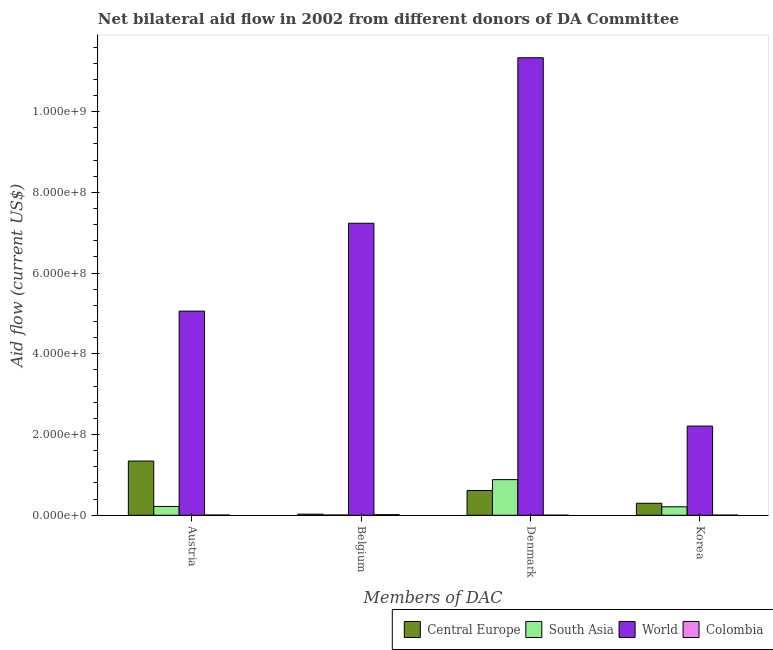How many different coloured bars are there?
Offer a terse response. 4. How many groups of bars are there?
Provide a short and direct response. 4. Are the number of bars on each tick of the X-axis equal?
Keep it short and to the point. Yes. How many bars are there on the 2nd tick from the left?
Provide a short and direct response. 4. What is the label of the 1st group of bars from the left?
Your answer should be very brief. Austria. What is the amount of aid given by austria in Colombia?
Provide a succinct answer. 5.50e+05. Across all countries, what is the maximum amount of aid given by denmark?
Offer a terse response. 1.13e+09. Across all countries, what is the minimum amount of aid given by belgium?
Your response must be concise. 6.20e+05. In which country was the amount of aid given by korea maximum?
Give a very brief answer. World. What is the total amount of aid given by denmark in the graph?
Your answer should be compact. 1.28e+09. What is the difference between the amount of aid given by denmark in South Asia and that in Colombia?
Your answer should be compact. 8.81e+07. What is the difference between the amount of aid given by korea in World and the amount of aid given by austria in Central Europe?
Give a very brief answer. 8.66e+07. What is the average amount of aid given by denmark per country?
Offer a very short reply. 3.21e+08. What is the difference between the amount of aid given by austria and amount of aid given by korea in Colombia?
Ensure brevity in your answer.  1.80e+05. What is the ratio of the amount of aid given by korea in Central Europe to that in South Asia?
Make the answer very short. 1.42. Is the difference between the amount of aid given by belgium in South Asia and Colombia greater than the difference between the amount of aid given by austria in South Asia and Colombia?
Keep it short and to the point. No. What is the difference between the highest and the second highest amount of aid given by denmark?
Your response must be concise. 1.05e+09. What is the difference between the highest and the lowest amount of aid given by korea?
Offer a terse response. 2.21e+08. What does the 2nd bar from the left in Denmark represents?
Your answer should be compact. South Asia. What does the 4th bar from the right in Belgium represents?
Provide a succinct answer. Central Europe. Is it the case that in every country, the sum of the amount of aid given by austria and amount of aid given by belgium is greater than the amount of aid given by denmark?
Your response must be concise. No. How many bars are there?
Ensure brevity in your answer.  16. Are all the bars in the graph horizontal?
Make the answer very short. No. Does the graph contain any zero values?
Your answer should be very brief. No. Does the graph contain grids?
Keep it short and to the point. No. How are the legend labels stacked?
Give a very brief answer. Horizontal. What is the title of the graph?
Ensure brevity in your answer.  Net bilateral aid flow in 2002 from different donors of DA Committee. Does "High income: OECD" appear as one of the legend labels in the graph?
Provide a short and direct response. No. What is the label or title of the X-axis?
Offer a terse response. Members of DAC. What is the Aid flow (current US$) in Central Europe in Austria?
Give a very brief answer. 1.34e+08. What is the Aid flow (current US$) of South Asia in Austria?
Provide a succinct answer. 2.18e+07. What is the Aid flow (current US$) of World in Austria?
Offer a terse response. 5.06e+08. What is the Aid flow (current US$) of Central Europe in Belgium?
Offer a terse response. 2.75e+06. What is the Aid flow (current US$) in South Asia in Belgium?
Ensure brevity in your answer.  6.20e+05. What is the Aid flow (current US$) of World in Belgium?
Offer a very short reply. 7.23e+08. What is the Aid flow (current US$) in Colombia in Belgium?
Your response must be concise. 1.44e+06. What is the Aid flow (current US$) of Central Europe in Denmark?
Offer a terse response. 6.13e+07. What is the Aid flow (current US$) in South Asia in Denmark?
Your response must be concise. 8.83e+07. What is the Aid flow (current US$) of World in Denmark?
Keep it short and to the point. 1.13e+09. What is the Aid flow (current US$) of Colombia in Denmark?
Offer a very short reply. 1.90e+05. What is the Aid flow (current US$) in Central Europe in Korea?
Your answer should be very brief. 2.97e+07. What is the Aid flow (current US$) in South Asia in Korea?
Make the answer very short. 2.10e+07. What is the Aid flow (current US$) in World in Korea?
Your answer should be very brief. 2.21e+08. What is the Aid flow (current US$) in Colombia in Korea?
Keep it short and to the point. 3.70e+05. Across all Members of DAC, what is the maximum Aid flow (current US$) of Central Europe?
Provide a succinct answer. 1.34e+08. Across all Members of DAC, what is the maximum Aid flow (current US$) in South Asia?
Your answer should be compact. 8.83e+07. Across all Members of DAC, what is the maximum Aid flow (current US$) of World?
Give a very brief answer. 1.13e+09. Across all Members of DAC, what is the maximum Aid flow (current US$) in Colombia?
Keep it short and to the point. 1.44e+06. Across all Members of DAC, what is the minimum Aid flow (current US$) of Central Europe?
Your answer should be very brief. 2.75e+06. Across all Members of DAC, what is the minimum Aid flow (current US$) in South Asia?
Make the answer very short. 6.20e+05. Across all Members of DAC, what is the minimum Aid flow (current US$) of World?
Your answer should be very brief. 2.21e+08. Across all Members of DAC, what is the minimum Aid flow (current US$) in Colombia?
Offer a very short reply. 1.90e+05. What is the total Aid flow (current US$) of Central Europe in the graph?
Provide a succinct answer. 2.28e+08. What is the total Aid flow (current US$) in South Asia in the graph?
Offer a very short reply. 1.32e+08. What is the total Aid flow (current US$) in World in the graph?
Your answer should be compact. 2.58e+09. What is the total Aid flow (current US$) in Colombia in the graph?
Give a very brief answer. 2.55e+06. What is the difference between the Aid flow (current US$) of Central Europe in Austria and that in Belgium?
Provide a succinct answer. 1.32e+08. What is the difference between the Aid flow (current US$) in South Asia in Austria and that in Belgium?
Ensure brevity in your answer.  2.12e+07. What is the difference between the Aid flow (current US$) in World in Austria and that in Belgium?
Provide a short and direct response. -2.18e+08. What is the difference between the Aid flow (current US$) in Colombia in Austria and that in Belgium?
Ensure brevity in your answer.  -8.90e+05. What is the difference between the Aid flow (current US$) of Central Europe in Austria and that in Denmark?
Make the answer very short. 7.30e+07. What is the difference between the Aid flow (current US$) in South Asia in Austria and that in Denmark?
Make the answer very short. -6.64e+07. What is the difference between the Aid flow (current US$) in World in Austria and that in Denmark?
Provide a short and direct response. -6.28e+08. What is the difference between the Aid flow (current US$) in Central Europe in Austria and that in Korea?
Keep it short and to the point. 1.05e+08. What is the difference between the Aid flow (current US$) in South Asia in Austria and that in Korea?
Keep it short and to the point. 8.80e+05. What is the difference between the Aid flow (current US$) of World in Austria and that in Korea?
Ensure brevity in your answer.  2.85e+08. What is the difference between the Aid flow (current US$) in Central Europe in Belgium and that in Denmark?
Provide a succinct answer. -5.86e+07. What is the difference between the Aid flow (current US$) of South Asia in Belgium and that in Denmark?
Offer a terse response. -8.76e+07. What is the difference between the Aid flow (current US$) in World in Belgium and that in Denmark?
Provide a short and direct response. -4.10e+08. What is the difference between the Aid flow (current US$) of Colombia in Belgium and that in Denmark?
Your answer should be compact. 1.25e+06. What is the difference between the Aid flow (current US$) of Central Europe in Belgium and that in Korea?
Give a very brief answer. -2.69e+07. What is the difference between the Aid flow (current US$) in South Asia in Belgium and that in Korea?
Your answer should be compact. -2.03e+07. What is the difference between the Aid flow (current US$) in World in Belgium and that in Korea?
Keep it short and to the point. 5.03e+08. What is the difference between the Aid flow (current US$) in Colombia in Belgium and that in Korea?
Ensure brevity in your answer.  1.07e+06. What is the difference between the Aid flow (current US$) of Central Europe in Denmark and that in Korea?
Your answer should be compact. 3.16e+07. What is the difference between the Aid flow (current US$) in South Asia in Denmark and that in Korea?
Keep it short and to the point. 6.73e+07. What is the difference between the Aid flow (current US$) of World in Denmark and that in Korea?
Offer a terse response. 9.13e+08. What is the difference between the Aid flow (current US$) of Colombia in Denmark and that in Korea?
Keep it short and to the point. -1.80e+05. What is the difference between the Aid flow (current US$) in Central Europe in Austria and the Aid flow (current US$) in South Asia in Belgium?
Keep it short and to the point. 1.34e+08. What is the difference between the Aid flow (current US$) of Central Europe in Austria and the Aid flow (current US$) of World in Belgium?
Your response must be concise. -5.89e+08. What is the difference between the Aid flow (current US$) of Central Europe in Austria and the Aid flow (current US$) of Colombia in Belgium?
Give a very brief answer. 1.33e+08. What is the difference between the Aid flow (current US$) of South Asia in Austria and the Aid flow (current US$) of World in Belgium?
Your response must be concise. -7.02e+08. What is the difference between the Aid flow (current US$) in South Asia in Austria and the Aid flow (current US$) in Colombia in Belgium?
Give a very brief answer. 2.04e+07. What is the difference between the Aid flow (current US$) in World in Austria and the Aid flow (current US$) in Colombia in Belgium?
Give a very brief answer. 5.04e+08. What is the difference between the Aid flow (current US$) of Central Europe in Austria and the Aid flow (current US$) of South Asia in Denmark?
Provide a succinct answer. 4.61e+07. What is the difference between the Aid flow (current US$) of Central Europe in Austria and the Aid flow (current US$) of World in Denmark?
Provide a short and direct response. -9.99e+08. What is the difference between the Aid flow (current US$) of Central Europe in Austria and the Aid flow (current US$) of Colombia in Denmark?
Ensure brevity in your answer.  1.34e+08. What is the difference between the Aid flow (current US$) of South Asia in Austria and the Aid flow (current US$) of World in Denmark?
Provide a short and direct response. -1.11e+09. What is the difference between the Aid flow (current US$) in South Asia in Austria and the Aid flow (current US$) in Colombia in Denmark?
Your answer should be compact. 2.17e+07. What is the difference between the Aid flow (current US$) of World in Austria and the Aid flow (current US$) of Colombia in Denmark?
Offer a terse response. 5.06e+08. What is the difference between the Aid flow (current US$) of Central Europe in Austria and the Aid flow (current US$) of South Asia in Korea?
Your response must be concise. 1.13e+08. What is the difference between the Aid flow (current US$) of Central Europe in Austria and the Aid flow (current US$) of World in Korea?
Keep it short and to the point. -8.66e+07. What is the difference between the Aid flow (current US$) of Central Europe in Austria and the Aid flow (current US$) of Colombia in Korea?
Offer a very short reply. 1.34e+08. What is the difference between the Aid flow (current US$) of South Asia in Austria and the Aid flow (current US$) of World in Korea?
Offer a very short reply. -1.99e+08. What is the difference between the Aid flow (current US$) of South Asia in Austria and the Aid flow (current US$) of Colombia in Korea?
Give a very brief answer. 2.15e+07. What is the difference between the Aid flow (current US$) of World in Austria and the Aid flow (current US$) of Colombia in Korea?
Offer a terse response. 5.05e+08. What is the difference between the Aid flow (current US$) in Central Europe in Belgium and the Aid flow (current US$) in South Asia in Denmark?
Your response must be concise. -8.55e+07. What is the difference between the Aid flow (current US$) in Central Europe in Belgium and the Aid flow (current US$) in World in Denmark?
Your answer should be very brief. -1.13e+09. What is the difference between the Aid flow (current US$) in Central Europe in Belgium and the Aid flow (current US$) in Colombia in Denmark?
Provide a succinct answer. 2.56e+06. What is the difference between the Aid flow (current US$) in South Asia in Belgium and the Aid flow (current US$) in World in Denmark?
Provide a short and direct response. -1.13e+09. What is the difference between the Aid flow (current US$) in South Asia in Belgium and the Aid flow (current US$) in Colombia in Denmark?
Keep it short and to the point. 4.30e+05. What is the difference between the Aid flow (current US$) of World in Belgium and the Aid flow (current US$) of Colombia in Denmark?
Make the answer very short. 7.23e+08. What is the difference between the Aid flow (current US$) of Central Europe in Belgium and the Aid flow (current US$) of South Asia in Korea?
Offer a terse response. -1.82e+07. What is the difference between the Aid flow (current US$) of Central Europe in Belgium and the Aid flow (current US$) of World in Korea?
Your answer should be compact. -2.18e+08. What is the difference between the Aid flow (current US$) of Central Europe in Belgium and the Aid flow (current US$) of Colombia in Korea?
Make the answer very short. 2.38e+06. What is the difference between the Aid flow (current US$) of South Asia in Belgium and the Aid flow (current US$) of World in Korea?
Your answer should be very brief. -2.20e+08. What is the difference between the Aid flow (current US$) in South Asia in Belgium and the Aid flow (current US$) in Colombia in Korea?
Keep it short and to the point. 2.50e+05. What is the difference between the Aid flow (current US$) in World in Belgium and the Aid flow (current US$) in Colombia in Korea?
Offer a terse response. 7.23e+08. What is the difference between the Aid flow (current US$) of Central Europe in Denmark and the Aid flow (current US$) of South Asia in Korea?
Keep it short and to the point. 4.03e+07. What is the difference between the Aid flow (current US$) in Central Europe in Denmark and the Aid flow (current US$) in World in Korea?
Your answer should be compact. -1.60e+08. What is the difference between the Aid flow (current US$) in Central Europe in Denmark and the Aid flow (current US$) in Colombia in Korea?
Make the answer very short. 6.09e+07. What is the difference between the Aid flow (current US$) of South Asia in Denmark and the Aid flow (current US$) of World in Korea?
Give a very brief answer. -1.33e+08. What is the difference between the Aid flow (current US$) of South Asia in Denmark and the Aid flow (current US$) of Colombia in Korea?
Keep it short and to the point. 8.79e+07. What is the difference between the Aid flow (current US$) in World in Denmark and the Aid flow (current US$) in Colombia in Korea?
Offer a terse response. 1.13e+09. What is the average Aid flow (current US$) of Central Europe per Members of DAC?
Make the answer very short. 5.70e+07. What is the average Aid flow (current US$) in South Asia per Members of DAC?
Ensure brevity in your answer.  3.29e+07. What is the average Aid flow (current US$) of World per Members of DAC?
Give a very brief answer. 6.46e+08. What is the average Aid flow (current US$) in Colombia per Members of DAC?
Give a very brief answer. 6.38e+05. What is the difference between the Aid flow (current US$) in Central Europe and Aid flow (current US$) in South Asia in Austria?
Your answer should be compact. 1.12e+08. What is the difference between the Aid flow (current US$) of Central Europe and Aid flow (current US$) of World in Austria?
Give a very brief answer. -3.71e+08. What is the difference between the Aid flow (current US$) of Central Europe and Aid flow (current US$) of Colombia in Austria?
Keep it short and to the point. 1.34e+08. What is the difference between the Aid flow (current US$) in South Asia and Aid flow (current US$) in World in Austria?
Provide a succinct answer. -4.84e+08. What is the difference between the Aid flow (current US$) of South Asia and Aid flow (current US$) of Colombia in Austria?
Provide a succinct answer. 2.13e+07. What is the difference between the Aid flow (current US$) in World and Aid flow (current US$) in Colombia in Austria?
Offer a terse response. 5.05e+08. What is the difference between the Aid flow (current US$) in Central Europe and Aid flow (current US$) in South Asia in Belgium?
Keep it short and to the point. 2.13e+06. What is the difference between the Aid flow (current US$) of Central Europe and Aid flow (current US$) of World in Belgium?
Your answer should be compact. -7.21e+08. What is the difference between the Aid flow (current US$) of Central Europe and Aid flow (current US$) of Colombia in Belgium?
Give a very brief answer. 1.31e+06. What is the difference between the Aid flow (current US$) of South Asia and Aid flow (current US$) of World in Belgium?
Ensure brevity in your answer.  -7.23e+08. What is the difference between the Aid flow (current US$) in South Asia and Aid flow (current US$) in Colombia in Belgium?
Your response must be concise. -8.20e+05. What is the difference between the Aid flow (current US$) in World and Aid flow (current US$) in Colombia in Belgium?
Keep it short and to the point. 7.22e+08. What is the difference between the Aid flow (current US$) of Central Europe and Aid flow (current US$) of South Asia in Denmark?
Ensure brevity in your answer.  -2.70e+07. What is the difference between the Aid flow (current US$) in Central Europe and Aid flow (current US$) in World in Denmark?
Your answer should be compact. -1.07e+09. What is the difference between the Aid flow (current US$) in Central Europe and Aid flow (current US$) in Colombia in Denmark?
Your answer should be compact. 6.11e+07. What is the difference between the Aid flow (current US$) of South Asia and Aid flow (current US$) of World in Denmark?
Your answer should be very brief. -1.05e+09. What is the difference between the Aid flow (current US$) in South Asia and Aid flow (current US$) in Colombia in Denmark?
Offer a terse response. 8.81e+07. What is the difference between the Aid flow (current US$) of World and Aid flow (current US$) of Colombia in Denmark?
Provide a succinct answer. 1.13e+09. What is the difference between the Aid flow (current US$) in Central Europe and Aid flow (current US$) in South Asia in Korea?
Offer a very short reply. 8.72e+06. What is the difference between the Aid flow (current US$) of Central Europe and Aid flow (current US$) of World in Korea?
Your answer should be compact. -1.91e+08. What is the difference between the Aid flow (current US$) of Central Europe and Aid flow (current US$) of Colombia in Korea?
Give a very brief answer. 2.93e+07. What is the difference between the Aid flow (current US$) of South Asia and Aid flow (current US$) of World in Korea?
Make the answer very short. -2.00e+08. What is the difference between the Aid flow (current US$) of South Asia and Aid flow (current US$) of Colombia in Korea?
Your answer should be compact. 2.06e+07. What is the difference between the Aid flow (current US$) in World and Aid flow (current US$) in Colombia in Korea?
Offer a terse response. 2.21e+08. What is the ratio of the Aid flow (current US$) of Central Europe in Austria to that in Belgium?
Ensure brevity in your answer.  48.85. What is the ratio of the Aid flow (current US$) in South Asia in Austria to that in Belgium?
Ensure brevity in your answer.  35.24. What is the ratio of the Aid flow (current US$) in World in Austria to that in Belgium?
Ensure brevity in your answer.  0.7. What is the ratio of the Aid flow (current US$) in Colombia in Austria to that in Belgium?
Your answer should be very brief. 0.38. What is the ratio of the Aid flow (current US$) in Central Europe in Austria to that in Denmark?
Keep it short and to the point. 2.19. What is the ratio of the Aid flow (current US$) of South Asia in Austria to that in Denmark?
Provide a short and direct response. 0.25. What is the ratio of the Aid flow (current US$) in World in Austria to that in Denmark?
Offer a terse response. 0.45. What is the ratio of the Aid flow (current US$) of Colombia in Austria to that in Denmark?
Your response must be concise. 2.89. What is the ratio of the Aid flow (current US$) of Central Europe in Austria to that in Korea?
Offer a terse response. 4.52. What is the ratio of the Aid flow (current US$) in South Asia in Austria to that in Korea?
Your answer should be compact. 1.04. What is the ratio of the Aid flow (current US$) in World in Austria to that in Korea?
Give a very brief answer. 2.29. What is the ratio of the Aid flow (current US$) of Colombia in Austria to that in Korea?
Keep it short and to the point. 1.49. What is the ratio of the Aid flow (current US$) in Central Europe in Belgium to that in Denmark?
Your answer should be compact. 0.04. What is the ratio of the Aid flow (current US$) in South Asia in Belgium to that in Denmark?
Your answer should be compact. 0.01. What is the ratio of the Aid flow (current US$) of World in Belgium to that in Denmark?
Make the answer very short. 0.64. What is the ratio of the Aid flow (current US$) in Colombia in Belgium to that in Denmark?
Ensure brevity in your answer.  7.58. What is the ratio of the Aid flow (current US$) of Central Europe in Belgium to that in Korea?
Make the answer very short. 0.09. What is the ratio of the Aid flow (current US$) in South Asia in Belgium to that in Korea?
Give a very brief answer. 0.03. What is the ratio of the Aid flow (current US$) in World in Belgium to that in Korea?
Offer a very short reply. 3.27. What is the ratio of the Aid flow (current US$) of Colombia in Belgium to that in Korea?
Your answer should be very brief. 3.89. What is the ratio of the Aid flow (current US$) of Central Europe in Denmark to that in Korea?
Your answer should be very brief. 2.06. What is the ratio of the Aid flow (current US$) of South Asia in Denmark to that in Korea?
Your response must be concise. 4.21. What is the ratio of the Aid flow (current US$) in World in Denmark to that in Korea?
Give a very brief answer. 5.13. What is the ratio of the Aid flow (current US$) in Colombia in Denmark to that in Korea?
Offer a very short reply. 0.51. What is the difference between the highest and the second highest Aid flow (current US$) in Central Europe?
Give a very brief answer. 7.30e+07. What is the difference between the highest and the second highest Aid flow (current US$) in South Asia?
Provide a short and direct response. 6.64e+07. What is the difference between the highest and the second highest Aid flow (current US$) in World?
Your response must be concise. 4.10e+08. What is the difference between the highest and the second highest Aid flow (current US$) of Colombia?
Offer a very short reply. 8.90e+05. What is the difference between the highest and the lowest Aid flow (current US$) of Central Europe?
Your response must be concise. 1.32e+08. What is the difference between the highest and the lowest Aid flow (current US$) of South Asia?
Ensure brevity in your answer.  8.76e+07. What is the difference between the highest and the lowest Aid flow (current US$) of World?
Your response must be concise. 9.13e+08. What is the difference between the highest and the lowest Aid flow (current US$) of Colombia?
Make the answer very short. 1.25e+06. 